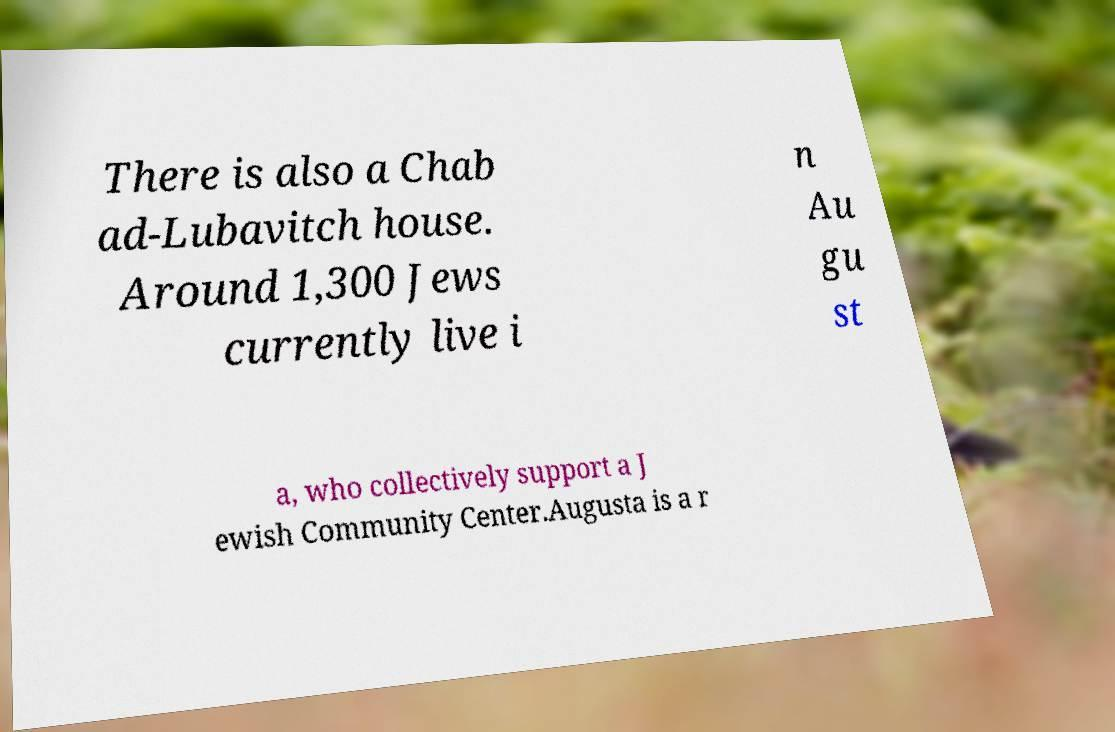What messages or text are displayed in this image? I need them in a readable, typed format. There is also a Chab ad-Lubavitch house. Around 1,300 Jews currently live i n Au gu st a, who collectively support a J ewish Community Center.Augusta is a r 